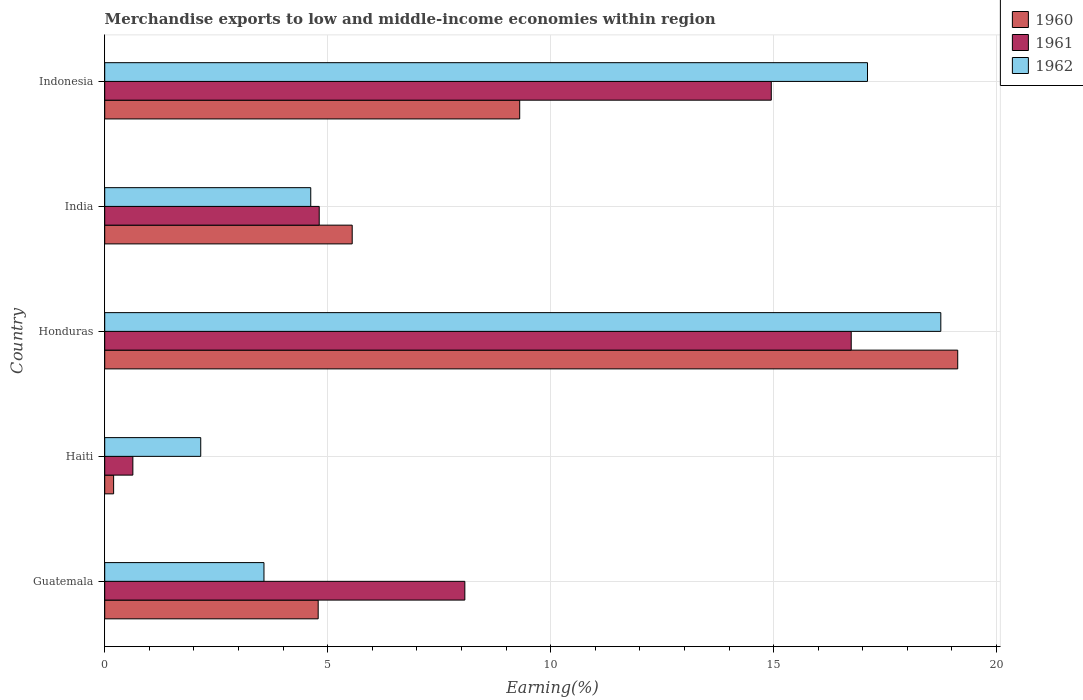Are the number of bars on each tick of the Y-axis equal?
Make the answer very short. Yes. What is the label of the 5th group of bars from the top?
Your answer should be compact. Guatemala. In how many cases, is the number of bars for a given country not equal to the number of legend labels?
Your response must be concise. 0. What is the percentage of amount earned from merchandise exports in 1960 in Haiti?
Offer a terse response. 0.2. Across all countries, what is the maximum percentage of amount earned from merchandise exports in 1961?
Your response must be concise. 16.74. Across all countries, what is the minimum percentage of amount earned from merchandise exports in 1962?
Provide a succinct answer. 2.15. In which country was the percentage of amount earned from merchandise exports in 1961 maximum?
Ensure brevity in your answer.  Honduras. In which country was the percentage of amount earned from merchandise exports in 1962 minimum?
Provide a succinct answer. Haiti. What is the total percentage of amount earned from merchandise exports in 1961 in the graph?
Give a very brief answer. 45.21. What is the difference between the percentage of amount earned from merchandise exports in 1961 in Honduras and that in Indonesia?
Your answer should be compact. 1.79. What is the difference between the percentage of amount earned from merchandise exports in 1960 in India and the percentage of amount earned from merchandise exports in 1961 in Haiti?
Provide a short and direct response. 4.92. What is the average percentage of amount earned from merchandise exports in 1960 per country?
Your answer should be very brief. 7.79. What is the difference between the percentage of amount earned from merchandise exports in 1960 and percentage of amount earned from merchandise exports in 1961 in Indonesia?
Provide a succinct answer. -5.64. What is the ratio of the percentage of amount earned from merchandise exports in 1962 in Honduras to that in Indonesia?
Give a very brief answer. 1.1. Is the percentage of amount earned from merchandise exports in 1962 in India less than that in Indonesia?
Your answer should be very brief. Yes. Is the difference between the percentage of amount earned from merchandise exports in 1960 in Guatemala and India greater than the difference between the percentage of amount earned from merchandise exports in 1961 in Guatemala and India?
Make the answer very short. No. What is the difference between the highest and the second highest percentage of amount earned from merchandise exports in 1962?
Provide a short and direct response. 1.64. What is the difference between the highest and the lowest percentage of amount earned from merchandise exports in 1961?
Offer a terse response. 16.11. In how many countries, is the percentage of amount earned from merchandise exports in 1962 greater than the average percentage of amount earned from merchandise exports in 1962 taken over all countries?
Your answer should be compact. 2. Is the sum of the percentage of amount earned from merchandise exports in 1961 in Guatemala and Honduras greater than the maximum percentage of amount earned from merchandise exports in 1962 across all countries?
Offer a terse response. Yes. What does the 1st bar from the bottom in India represents?
Offer a terse response. 1960. Is it the case that in every country, the sum of the percentage of amount earned from merchandise exports in 1960 and percentage of amount earned from merchandise exports in 1961 is greater than the percentage of amount earned from merchandise exports in 1962?
Your response must be concise. No. How many countries are there in the graph?
Your answer should be compact. 5. Are the values on the major ticks of X-axis written in scientific E-notation?
Give a very brief answer. No. Does the graph contain any zero values?
Your answer should be very brief. No. Where does the legend appear in the graph?
Ensure brevity in your answer.  Top right. How many legend labels are there?
Offer a terse response. 3. What is the title of the graph?
Keep it short and to the point. Merchandise exports to low and middle-income economies within region. What is the label or title of the X-axis?
Ensure brevity in your answer.  Earning(%). What is the Earning(%) of 1960 in Guatemala?
Offer a terse response. 4.79. What is the Earning(%) of 1961 in Guatemala?
Keep it short and to the point. 8.08. What is the Earning(%) in 1962 in Guatemala?
Make the answer very short. 3.57. What is the Earning(%) of 1960 in Haiti?
Give a very brief answer. 0.2. What is the Earning(%) of 1961 in Haiti?
Your answer should be compact. 0.63. What is the Earning(%) of 1962 in Haiti?
Your answer should be very brief. 2.15. What is the Earning(%) of 1960 in Honduras?
Offer a very short reply. 19.13. What is the Earning(%) in 1961 in Honduras?
Offer a terse response. 16.74. What is the Earning(%) of 1962 in Honduras?
Your answer should be compact. 18.75. What is the Earning(%) in 1960 in India?
Make the answer very short. 5.55. What is the Earning(%) of 1961 in India?
Offer a very short reply. 4.81. What is the Earning(%) of 1962 in India?
Provide a short and direct response. 4.62. What is the Earning(%) of 1960 in Indonesia?
Ensure brevity in your answer.  9.31. What is the Earning(%) of 1961 in Indonesia?
Provide a short and direct response. 14.95. What is the Earning(%) of 1962 in Indonesia?
Provide a succinct answer. 17.11. Across all countries, what is the maximum Earning(%) of 1960?
Offer a very short reply. 19.13. Across all countries, what is the maximum Earning(%) in 1961?
Your answer should be very brief. 16.74. Across all countries, what is the maximum Earning(%) of 1962?
Your response must be concise. 18.75. Across all countries, what is the minimum Earning(%) in 1960?
Provide a succinct answer. 0.2. Across all countries, what is the minimum Earning(%) in 1961?
Ensure brevity in your answer.  0.63. Across all countries, what is the minimum Earning(%) of 1962?
Keep it short and to the point. 2.15. What is the total Earning(%) in 1960 in the graph?
Ensure brevity in your answer.  38.97. What is the total Earning(%) of 1961 in the graph?
Provide a short and direct response. 45.21. What is the total Earning(%) of 1962 in the graph?
Give a very brief answer. 46.2. What is the difference between the Earning(%) of 1960 in Guatemala and that in Haiti?
Ensure brevity in your answer.  4.59. What is the difference between the Earning(%) in 1961 in Guatemala and that in Haiti?
Offer a terse response. 7.45. What is the difference between the Earning(%) of 1962 in Guatemala and that in Haiti?
Your response must be concise. 1.42. What is the difference between the Earning(%) in 1960 in Guatemala and that in Honduras?
Keep it short and to the point. -14.34. What is the difference between the Earning(%) in 1961 in Guatemala and that in Honduras?
Offer a very short reply. -8.66. What is the difference between the Earning(%) in 1962 in Guatemala and that in Honduras?
Provide a short and direct response. -15.18. What is the difference between the Earning(%) in 1960 in Guatemala and that in India?
Your answer should be very brief. -0.76. What is the difference between the Earning(%) in 1961 in Guatemala and that in India?
Your answer should be compact. 3.27. What is the difference between the Earning(%) of 1962 in Guatemala and that in India?
Your answer should be very brief. -1.05. What is the difference between the Earning(%) of 1960 in Guatemala and that in Indonesia?
Your answer should be compact. -4.52. What is the difference between the Earning(%) of 1961 in Guatemala and that in Indonesia?
Ensure brevity in your answer.  -6.87. What is the difference between the Earning(%) in 1962 in Guatemala and that in Indonesia?
Make the answer very short. -13.53. What is the difference between the Earning(%) in 1960 in Haiti and that in Honduras?
Your response must be concise. -18.93. What is the difference between the Earning(%) in 1961 in Haiti and that in Honduras?
Keep it short and to the point. -16.11. What is the difference between the Earning(%) in 1962 in Haiti and that in Honduras?
Offer a very short reply. -16.6. What is the difference between the Earning(%) of 1960 in Haiti and that in India?
Give a very brief answer. -5.35. What is the difference between the Earning(%) in 1961 in Haiti and that in India?
Keep it short and to the point. -4.18. What is the difference between the Earning(%) of 1962 in Haiti and that in India?
Keep it short and to the point. -2.47. What is the difference between the Earning(%) of 1960 in Haiti and that in Indonesia?
Ensure brevity in your answer.  -9.11. What is the difference between the Earning(%) of 1961 in Haiti and that in Indonesia?
Keep it short and to the point. -14.32. What is the difference between the Earning(%) of 1962 in Haiti and that in Indonesia?
Offer a terse response. -14.95. What is the difference between the Earning(%) in 1960 in Honduras and that in India?
Make the answer very short. 13.58. What is the difference between the Earning(%) of 1961 in Honduras and that in India?
Offer a terse response. 11.93. What is the difference between the Earning(%) of 1962 in Honduras and that in India?
Your response must be concise. 14.13. What is the difference between the Earning(%) of 1960 in Honduras and that in Indonesia?
Make the answer very short. 9.82. What is the difference between the Earning(%) of 1961 in Honduras and that in Indonesia?
Keep it short and to the point. 1.79. What is the difference between the Earning(%) in 1962 in Honduras and that in Indonesia?
Your answer should be very brief. 1.64. What is the difference between the Earning(%) of 1960 in India and that in Indonesia?
Give a very brief answer. -3.76. What is the difference between the Earning(%) of 1961 in India and that in Indonesia?
Give a very brief answer. -10.14. What is the difference between the Earning(%) of 1962 in India and that in Indonesia?
Your answer should be very brief. -12.49. What is the difference between the Earning(%) of 1960 in Guatemala and the Earning(%) of 1961 in Haiti?
Ensure brevity in your answer.  4.16. What is the difference between the Earning(%) of 1960 in Guatemala and the Earning(%) of 1962 in Haiti?
Offer a very short reply. 2.63. What is the difference between the Earning(%) of 1961 in Guatemala and the Earning(%) of 1962 in Haiti?
Give a very brief answer. 5.92. What is the difference between the Earning(%) of 1960 in Guatemala and the Earning(%) of 1961 in Honduras?
Ensure brevity in your answer.  -11.95. What is the difference between the Earning(%) in 1960 in Guatemala and the Earning(%) in 1962 in Honduras?
Provide a succinct answer. -13.96. What is the difference between the Earning(%) of 1961 in Guatemala and the Earning(%) of 1962 in Honduras?
Make the answer very short. -10.67. What is the difference between the Earning(%) in 1960 in Guatemala and the Earning(%) in 1961 in India?
Your answer should be very brief. -0.02. What is the difference between the Earning(%) of 1960 in Guatemala and the Earning(%) of 1962 in India?
Your answer should be very brief. 0.17. What is the difference between the Earning(%) of 1961 in Guatemala and the Earning(%) of 1962 in India?
Offer a terse response. 3.46. What is the difference between the Earning(%) of 1960 in Guatemala and the Earning(%) of 1961 in Indonesia?
Provide a short and direct response. -10.16. What is the difference between the Earning(%) in 1960 in Guatemala and the Earning(%) in 1962 in Indonesia?
Ensure brevity in your answer.  -12.32. What is the difference between the Earning(%) of 1961 in Guatemala and the Earning(%) of 1962 in Indonesia?
Your answer should be very brief. -9.03. What is the difference between the Earning(%) of 1960 in Haiti and the Earning(%) of 1961 in Honduras?
Your answer should be very brief. -16.54. What is the difference between the Earning(%) in 1960 in Haiti and the Earning(%) in 1962 in Honduras?
Your answer should be compact. -18.55. What is the difference between the Earning(%) in 1961 in Haiti and the Earning(%) in 1962 in Honduras?
Your response must be concise. -18.12. What is the difference between the Earning(%) of 1960 in Haiti and the Earning(%) of 1961 in India?
Keep it short and to the point. -4.61. What is the difference between the Earning(%) of 1960 in Haiti and the Earning(%) of 1962 in India?
Your response must be concise. -4.42. What is the difference between the Earning(%) in 1961 in Haiti and the Earning(%) in 1962 in India?
Your answer should be very brief. -3.99. What is the difference between the Earning(%) in 1960 in Haiti and the Earning(%) in 1961 in Indonesia?
Your response must be concise. -14.75. What is the difference between the Earning(%) in 1960 in Haiti and the Earning(%) in 1962 in Indonesia?
Ensure brevity in your answer.  -16.91. What is the difference between the Earning(%) of 1961 in Haiti and the Earning(%) of 1962 in Indonesia?
Make the answer very short. -16.47. What is the difference between the Earning(%) in 1960 in Honduras and the Earning(%) in 1961 in India?
Offer a very short reply. 14.32. What is the difference between the Earning(%) in 1960 in Honduras and the Earning(%) in 1962 in India?
Make the answer very short. 14.51. What is the difference between the Earning(%) of 1961 in Honduras and the Earning(%) of 1962 in India?
Your answer should be very brief. 12.12. What is the difference between the Earning(%) of 1960 in Honduras and the Earning(%) of 1961 in Indonesia?
Offer a very short reply. 4.18. What is the difference between the Earning(%) in 1960 in Honduras and the Earning(%) in 1962 in Indonesia?
Give a very brief answer. 2.02. What is the difference between the Earning(%) of 1961 in Honduras and the Earning(%) of 1962 in Indonesia?
Your answer should be very brief. -0.37. What is the difference between the Earning(%) of 1960 in India and the Earning(%) of 1961 in Indonesia?
Keep it short and to the point. -9.4. What is the difference between the Earning(%) of 1960 in India and the Earning(%) of 1962 in Indonesia?
Give a very brief answer. -11.56. What is the difference between the Earning(%) in 1961 in India and the Earning(%) in 1962 in Indonesia?
Offer a terse response. -12.3. What is the average Earning(%) of 1960 per country?
Offer a very short reply. 7.79. What is the average Earning(%) in 1961 per country?
Give a very brief answer. 9.04. What is the average Earning(%) in 1962 per country?
Keep it short and to the point. 9.24. What is the difference between the Earning(%) of 1960 and Earning(%) of 1961 in Guatemala?
Your answer should be compact. -3.29. What is the difference between the Earning(%) of 1960 and Earning(%) of 1962 in Guatemala?
Your response must be concise. 1.22. What is the difference between the Earning(%) of 1961 and Earning(%) of 1962 in Guatemala?
Your response must be concise. 4.5. What is the difference between the Earning(%) in 1960 and Earning(%) in 1961 in Haiti?
Ensure brevity in your answer.  -0.43. What is the difference between the Earning(%) in 1960 and Earning(%) in 1962 in Haiti?
Make the answer very short. -1.95. What is the difference between the Earning(%) in 1961 and Earning(%) in 1962 in Haiti?
Keep it short and to the point. -1.52. What is the difference between the Earning(%) of 1960 and Earning(%) of 1961 in Honduras?
Your answer should be compact. 2.39. What is the difference between the Earning(%) in 1960 and Earning(%) in 1962 in Honduras?
Your response must be concise. 0.38. What is the difference between the Earning(%) in 1961 and Earning(%) in 1962 in Honduras?
Provide a short and direct response. -2.01. What is the difference between the Earning(%) in 1960 and Earning(%) in 1961 in India?
Offer a terse response. 0.74. What is the difference between the Earning(%) in 1960 and Earning(%) in 1962 in India?
Ensure brevity in your answer.  0.93. What is the difference between the Earning(%) of 1961 and Earning(%) of 1962 in India?
Offer a terse response. 0.19. What is the difference between the Earning(%) of 1960 and Earning(%) of 1961 in Indonesia?
Your response must be concise. -5.64. What is the difference between the Earning(%) in 1960 and Earning(%) in 1962 in Indonesia?
Provide a succinct answer. -7.8. What is the difference between the Earning(%) in 1961 and Earning(%) in 1962 in Indonesia?
Keep it short and to the point. -2.16. What is the ratio of the Earning(%) in 1960 in Guatemala to that in Haiti?
Provide a succinct answer. 23.97. What is the ratio of the Earning(%) in 1961 in Guatemala to that in Haiti?
Offer a very short reply. 12.79. What is the ratio of the Earning(%) of 1962 in Guatemala to that in Haiti?
Your answer should be very brief. 1.66. What is the ratio of the Earning(%) in 1960 in Guatemala to that in Honduras?
Provide a succinct answer. 0.25. What is the ratio of the Earning(%) in 1961 in Guatemala to that in Honduras?
Ensure brevity in your answer.  0.48. What is the ratio of the Earning(%) of 1962 in Guatemala to that in Honduras?
Your answer should be very brief. 0.19. What is the ratio of the Earning(%) in 1960 in Guatemala to that in India?
Ensure brevity in your answer.  0.86. What is the ratio of the Earning(%) of 1961 in Guatemala to that in India?
Offer a terse response. 1.68. What is the ratio of the Earning(%) in 1962 in Guatemala to that in India?
Provide a short and direct response. 0.77. What is the ratio of the Earning(%) of 1960 in Guatemala to that in Indonesia?
Offer a terse response. 0.51. What is the ratio of the Earning(%) of 1961 in Guatemala to that in Indonesia?
Keep it short and to the point. 0.54. What is the ratio of the Earning(%) in 1962 in Guatemala to that in Indonesia?
Make the answer very short. 0.21. What is the ratio of the Earning(%) in 1960 in Haiti to that in Honduras?
Make the answer very short. 0.01. What is the ratio of the Earning(%) of 1961 in Haiti to that in Honduras?
Offer a terse response. 0.04. What is the ratio of the Earning(%) in 1962 in Haiti to that in Honduras?
Offer a very short reply. 0.11. What is the ratio of the Earning(%) in 1960 in Haiti to that in India?
Offer a very short reply. 0.04. What is the ratio of the Earning(%) of 1961 in Haiti to that in India?
Give a very brief answer. 0.13. What is the ratio of the Earning(%) of 1962 in Haiti to that in India?
Provide a succinct answer. 0.47. What is the ratio of the Earning(%) of 1960 in Haiti to that in Indonesia?
Ensure brevity in your answer.  0.02. What is the ratio of the Earning(%) of 1961 in Haiti to that in Indonesia?
Provide a short and direct response. 0.04. What is the ratio of the Earning(%) of 1962 in Haiti to that in Indonesia?
Ensure brevity in your answer.  0.13. What is the ratio of the Earning(%) in 1960 in Honduras to that in India?
Your response must be concise. 3.45. What is the ratio of the Earning(%) in 1961 in Honduras to that in India?
Your answer should be very brief. 3.48. What is the ratio of the Earning(%) of 1962 in Honduras to that in India?
Give a very brief answer. 4.06. What is the ratio of the Earning(%) in 1960 in Honduras to that in Indonesia?
Make the answer very short. 2.06. What is the ratio of the Earning(%) of 1961 in Honduras to that in Indonesia?
Offer a very short reply. 1.12. What is the ratio of the Earning(%) of 1962 in Honduras to that in Indonesia?
Offer a very short reply. 1.1. What is the ratio of the Earning(%) of 1960 in India to that in Indonesia?
Ensure brevity in your answer.  0.6. What is the ratio of the Earning(%) in 1961 in India to that in Indonesia?
Provide a succinct answer. 0.32. What is the ratio of the Earning(%) in 1962 in India to that in Indonesia?
Offer a very short reply. 0.27. What is the difference between the highest and the second highest Earning(%) of 1960?
Your response must be concise. 9.82. What is the difference between the highest and the second highest Earning(%) in 1961?
Offer a very short reply. 1.79. What is the difference between the highest and the second highest Earning(%) in 1962?
Offer a terse response. 1.64. What is the difference between the highest and the lowest Earning(%) in 1960?
Offer a very short reply. 18.93. What is the difference between the highest and the lowest Earning(%) in 1961?
Your answer should be very brief. 16.11. What is the difference between the highest and the lowest Earning(%) of 1962?
Your response must be concise. 16.6. 